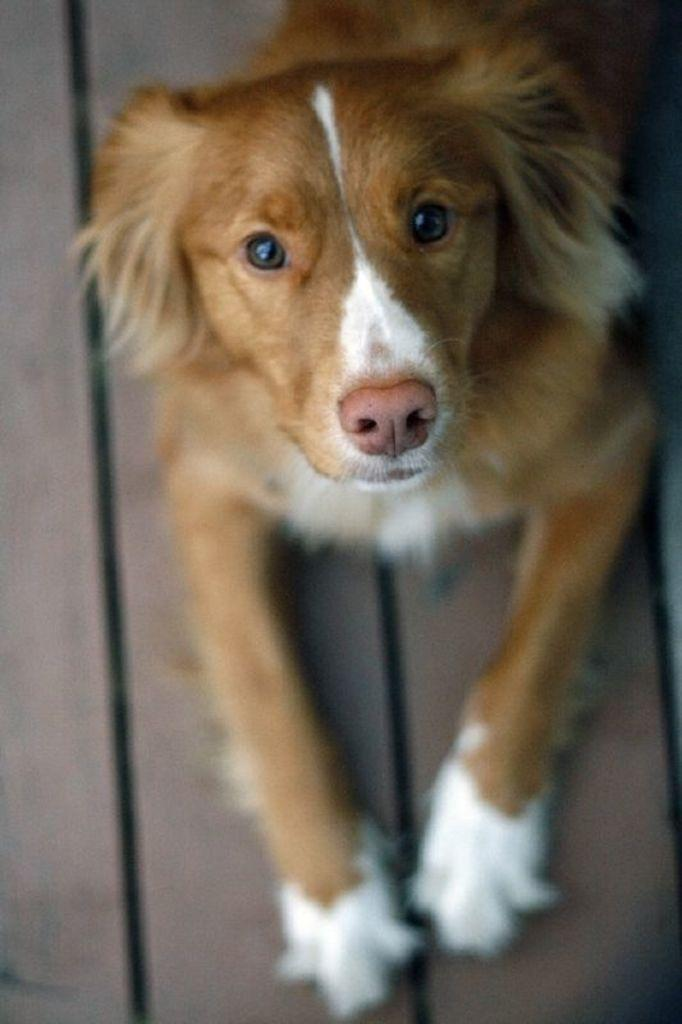What animal is present in the image? There is a dog in the image. What is the dog doing in the image? The dog is sitting on the ground. What type of popcorn is the dog eating in the image? There is no popcorn present in the image, and the dog is not eating anything. 